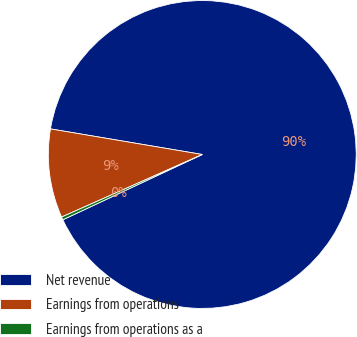Convert chart to OTSL. <chart><loc_0><loc_0><loc_500><loc_500><pie_chart><fcel>Net revenue<fcel>Earnings from operations<fcel>Earnings from operations as a<nl><fcel>90.38%<fcel>9.32%<fcel>0.31%<nl></chart> 